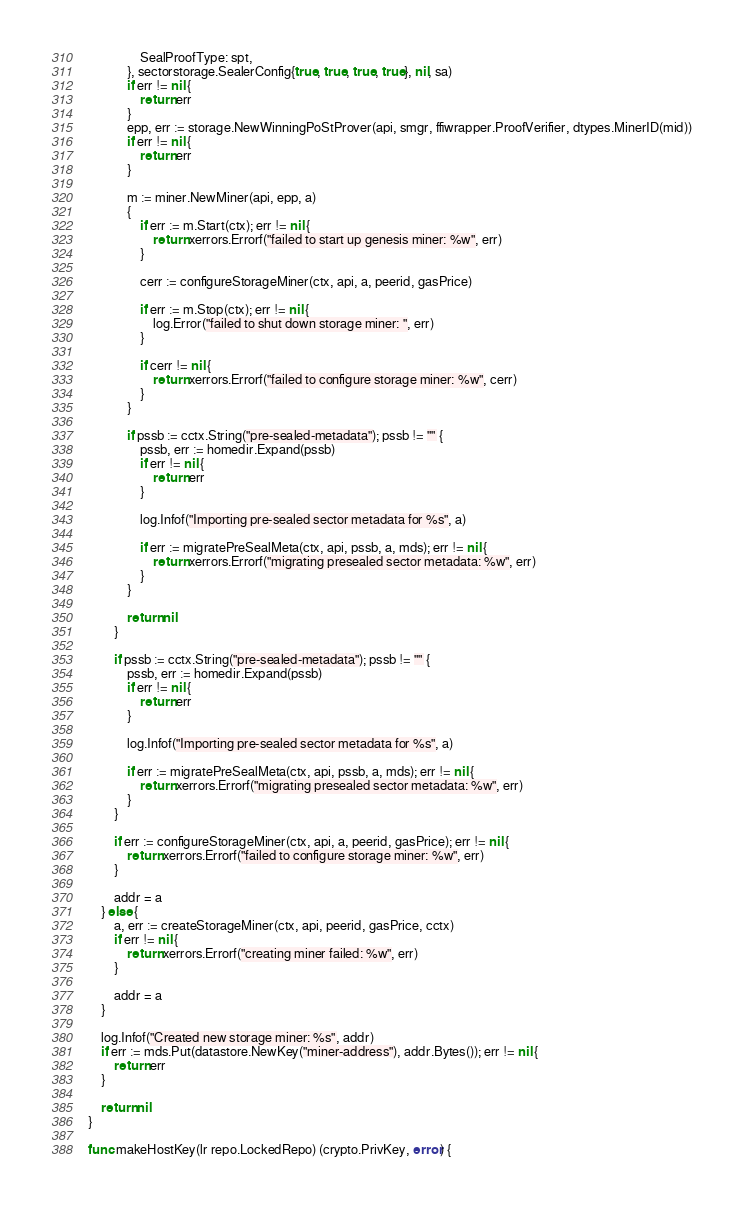Convert code to text. <code><loc_0><loc_0><loc_500><loc_500><_Go_>				SealProofType: spt,
			}, sectorstorage.SealerConfig{true, true, true, true}, nil, sa)
			if err != nil {
				return err
			}
			epp, err := storage.NewWinningPoStProver(api, smgr, ffiwrapper.ProofVerifier, dtypes.MinerID(mid))
			if err != nil {
				return err
			}

			m := miner.NewMiner(api, epp, a)
			{
				if err := m.Start(ctx); err != nil {
					return xerrors.Errorf("failed to start up genesis miner: %w", err)
				}

				cerr := configureStorageMiner(ctx, api, a, peerid, gasPrice)

				if err := m.Stop(ctx); err != nil {
					log.Error("failed to shut down storage miner: ", err)
				}

				if cerr != nil {
					return xerrors.Errorf("failed to configure storage miner: %w", cerr)
				}
			}

			if pssb := cctx.String("pre-sealed-metadata"); pssb != "" {
				pssb, err := homedir.Expand(pssb)
				if err != nil {
					return err
				}

				log.Infof("Importing pre-sealed sector metadata for %s", a)

				if err := migratePreSealMeta(ctx, api, pssb, a, mds); err != nil {
					return xerrors.Errorf("migrating presealed sector metadata: %w", err)
				}
			}

			return nil
		}

		if pssb := cctx.String("pre-sealed-metadata"); pssb != "" {
			pssb, err := homedir.Expand(pssb)
			if err != nil {
				return err
			}

			log.Infof("Importing pre-sealed sector metadata for %s", a)

			if err := migratePreSealMeta(ctx, api, pssb, a, mds); err != nil {
				return xerrors.Errorf("migrating presealed sector metadata: %w", err)
			}
		}

		if err := configureStorageMiner(ctx, api, a, peerid, gasPrice); err != nil {
			return xerrors.Errorf("failed to configure storage miner: %w", err)
		}

		addr = a
	} else {
		a, err := createStorageMiner(ctx, api, peerid, gasPrice, cctx)
		if err != nil {
			return xerrors.Errorf("creating miner failed: %w", err)
		}

		addr = a
	}

	log.Infof("Created new storage miner: %s", addr)
	if err := mds.Put(datastore.NewKey("miner-address"), addr.Bytes()); err != nil {
		return err
	}

	return nil
}

func makeHostKey(lr repo.LockedRepo) (crypto.PrivKey, error) {</code> 